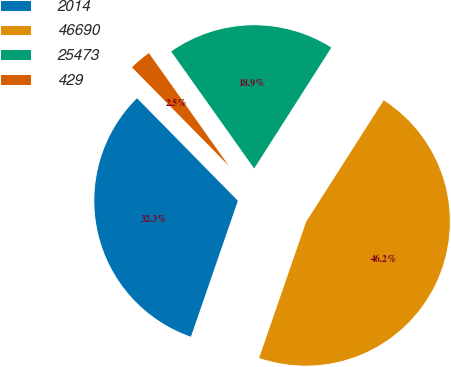<chart> <loc_0><loc_0><loc_500><loc_500><pie_chart><fcel>2014<fcel>46690<fcel>25473<fcel>429<nl><fcel>32.34%<fcel>46.25%<fcel>18.86%<fcel>2.55%<nl></chart> 